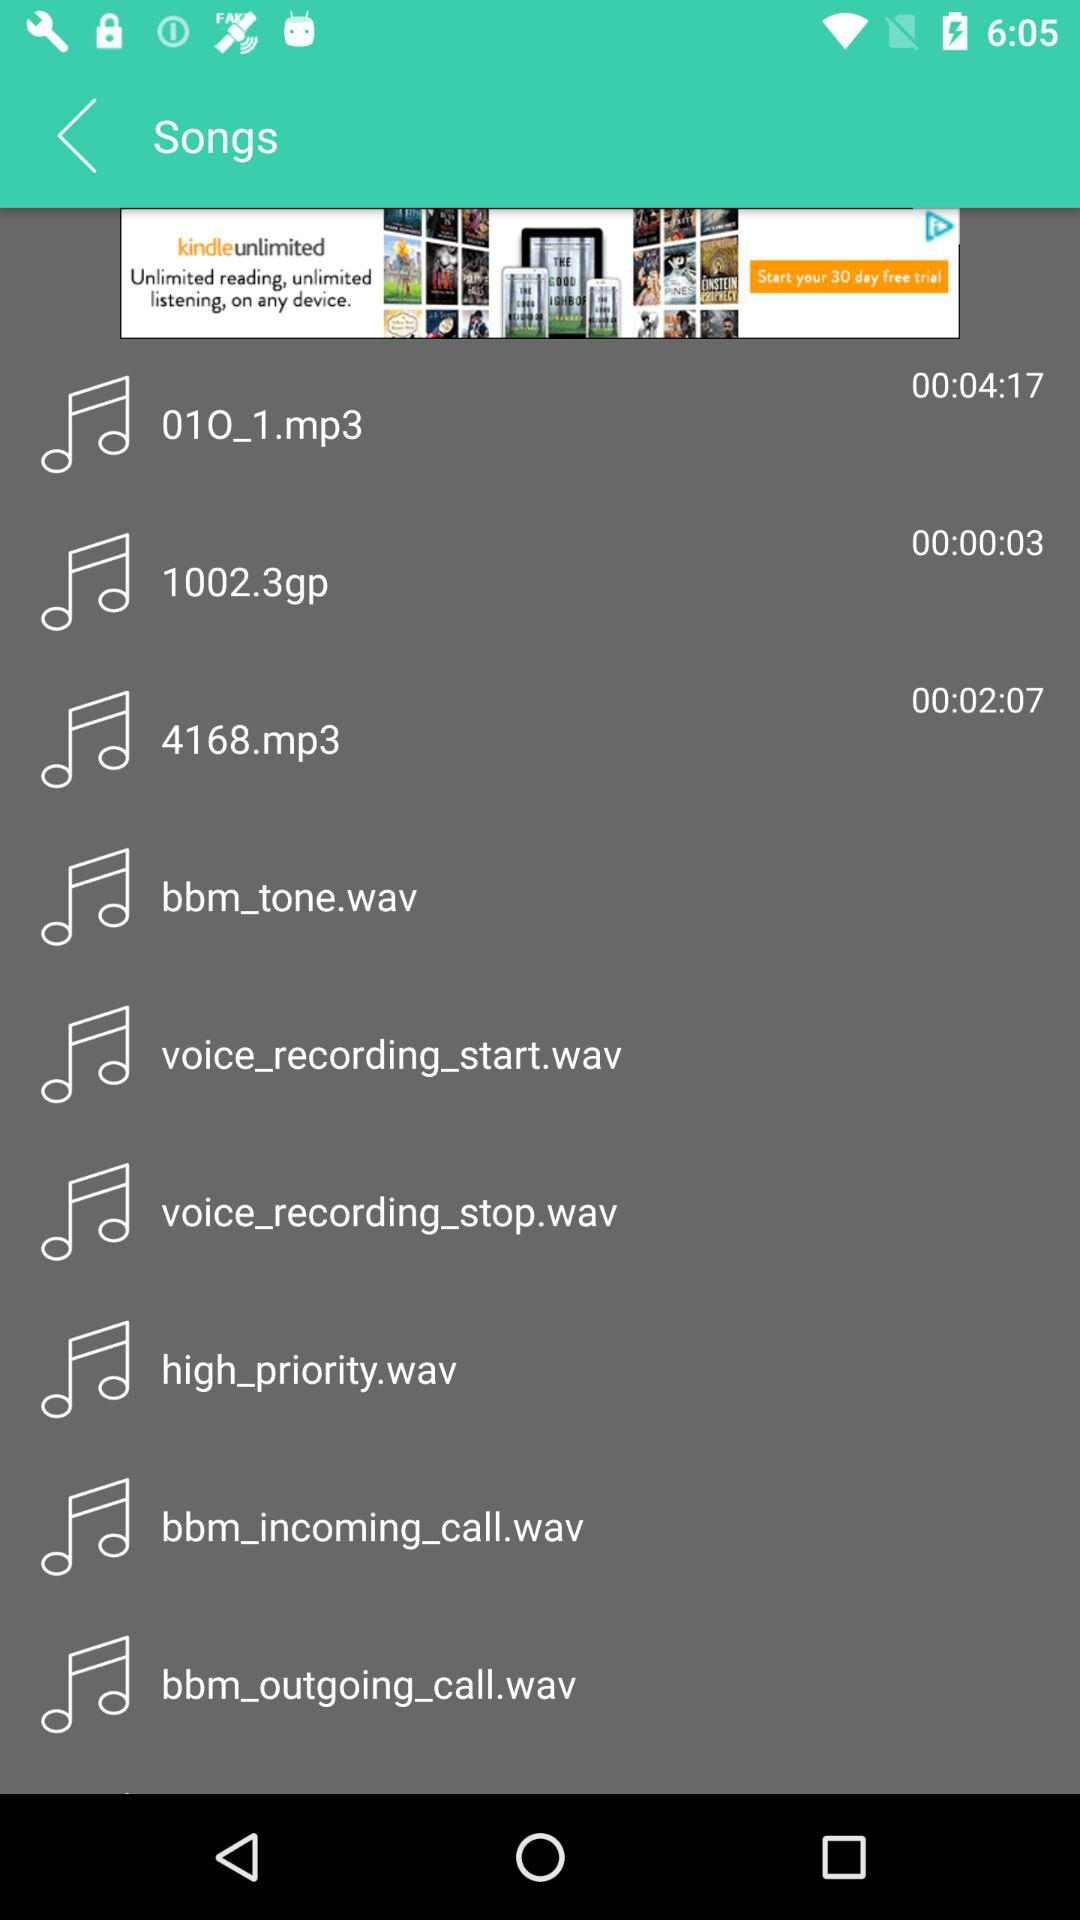What's the duration of the track "4168.mp3"? The duration is 2 minutes and 7 seconds. 